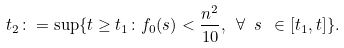Convert formula to latex. <formula><loc_0><loc_0><loc_500><loc_500>t _ { 2 } \colon = \sup \{ t \geq t _ { 1 } \colon f _ { 0 } ( s ) < \frac { n ^ { 2 } } { 1 0 } , \ \forall \ s \ \in [ t _ { 1 } , t ] \} .</formula> 